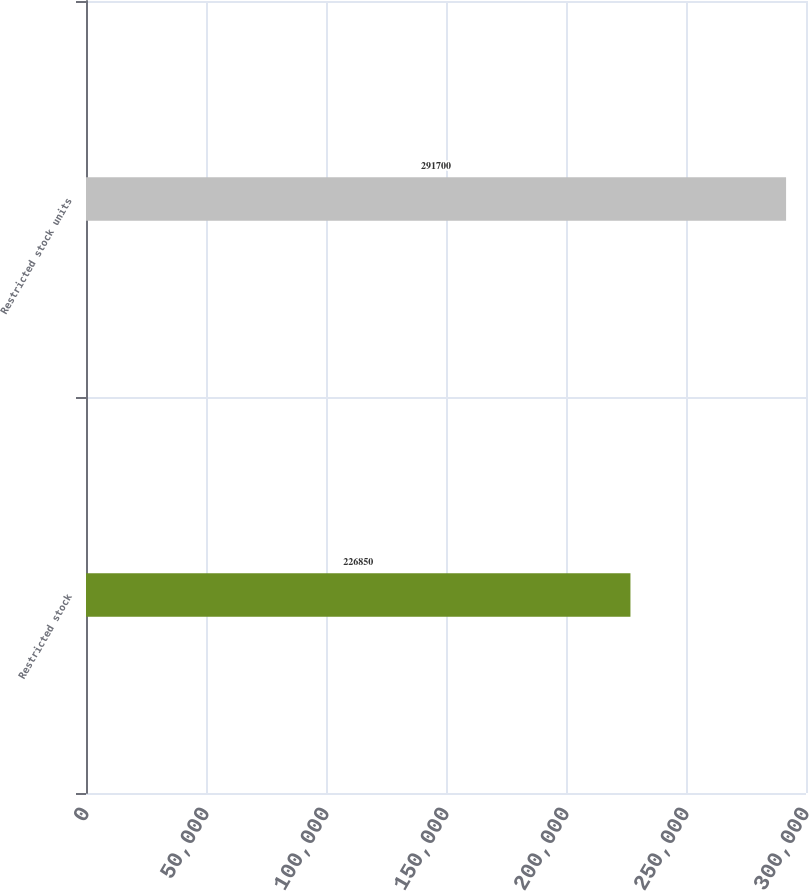<chart> <loc_0><loc_0><loc_500><loc_500><bar_chart><fcel>Restricted stock<fcel>Restricted stock units<nl><fcel>226850<fcel>291700<nl></chart> 